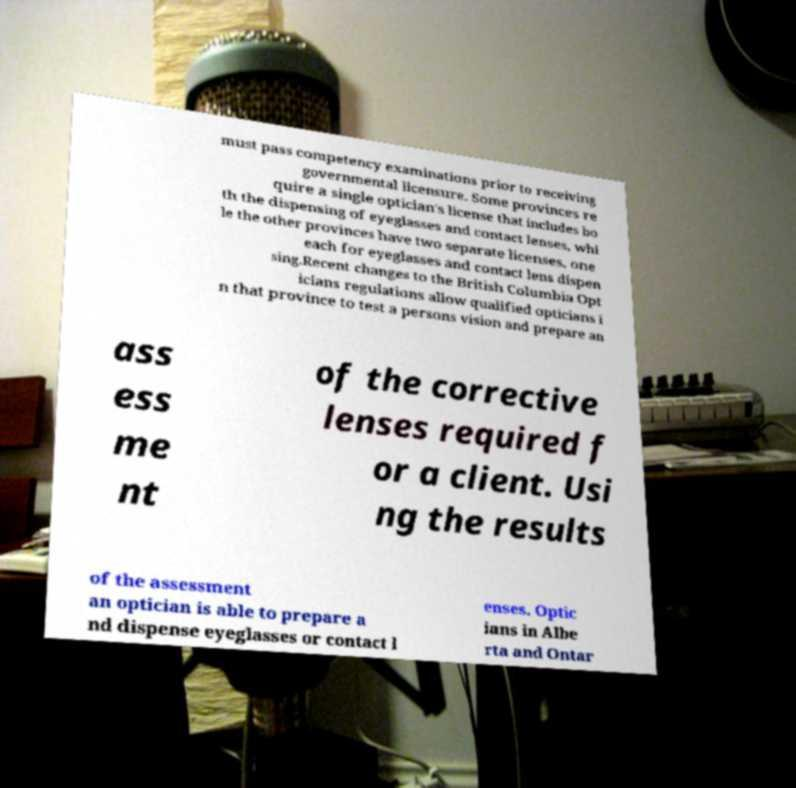Could you assist in decoding the text presented in this image and type it out clearly? must pass competency examinations prior to receiving governmental licensure. Some provinces re quire a single optician's license that includes bo th the dispensing of eyeglasses and contact lenses, whi le the other provinces have two separate licenses, one each for eyeglasses and contact lens dispen sing.Recent changes to the British Columbia Opt icians regulations allow qualified opticians i n that province to test a persons vision and prepare an ass ess me nt of the corrective lenses required f or a client. Usi ng the results of the assessment an optician is able to prepare a nd dispense eyeglasses or contact l enses. Optic ians in Albe rta and Ontar 